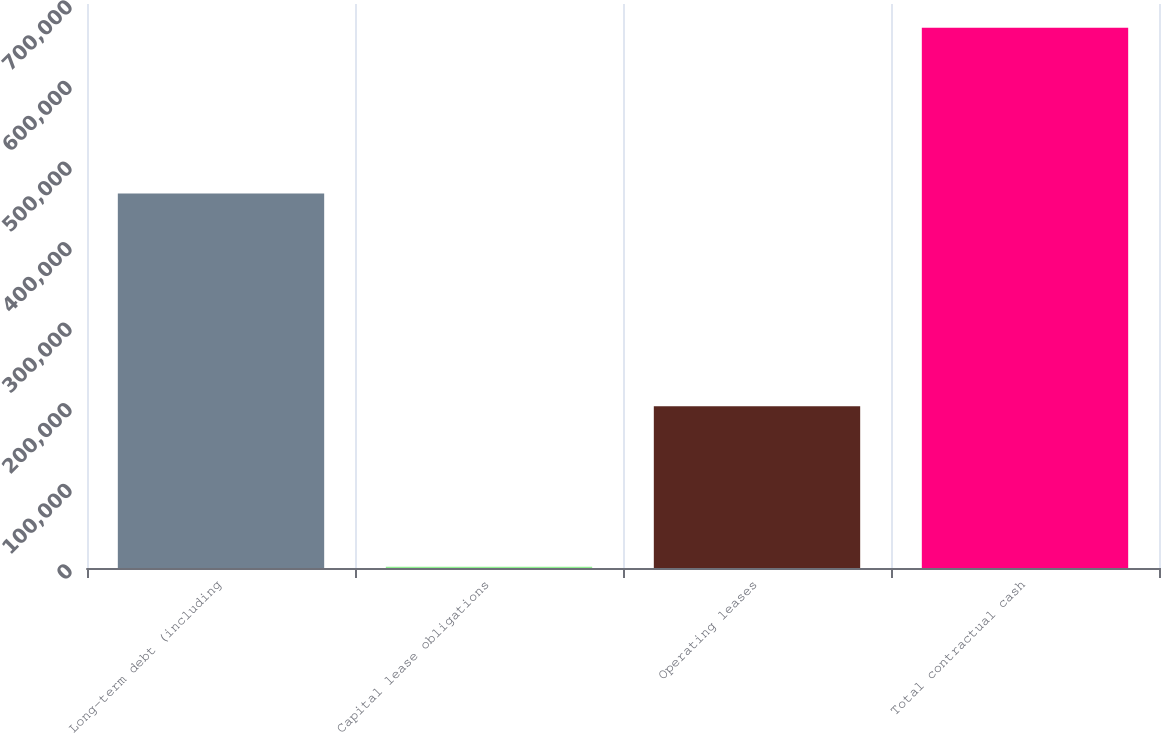Convert chart. <chart><loc_0><loc_0><loc_500><loc_500><bar_chart><fcel>Long-term debt (including<fcel>Capital lease obligations<fcel>Operating leases<fcel>Total contractual cash<nl><fcel>464898<fcel>1545<fcel>200639<fcel>670396<nl></chart> 